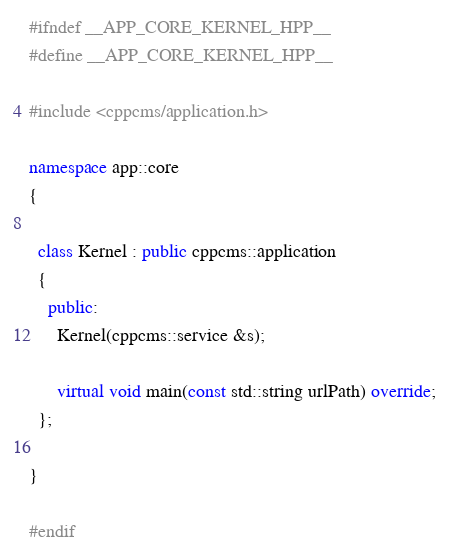<code> <loc_0><loc_0><loc_500><loc_500><_C++_>#ifndef __APP_CORE_KERNEL_HPP__
#define __APP_CORE_KERNEL_HPP__

#include <cppcms/application.h>

namespace app::core
{

  class Kernel : public cppcms::application
  {
    public:
      Kernel(cppcms::service &s);

      virtual void main(const std::string urlPath) override;
  };

}

#endif

</code> 